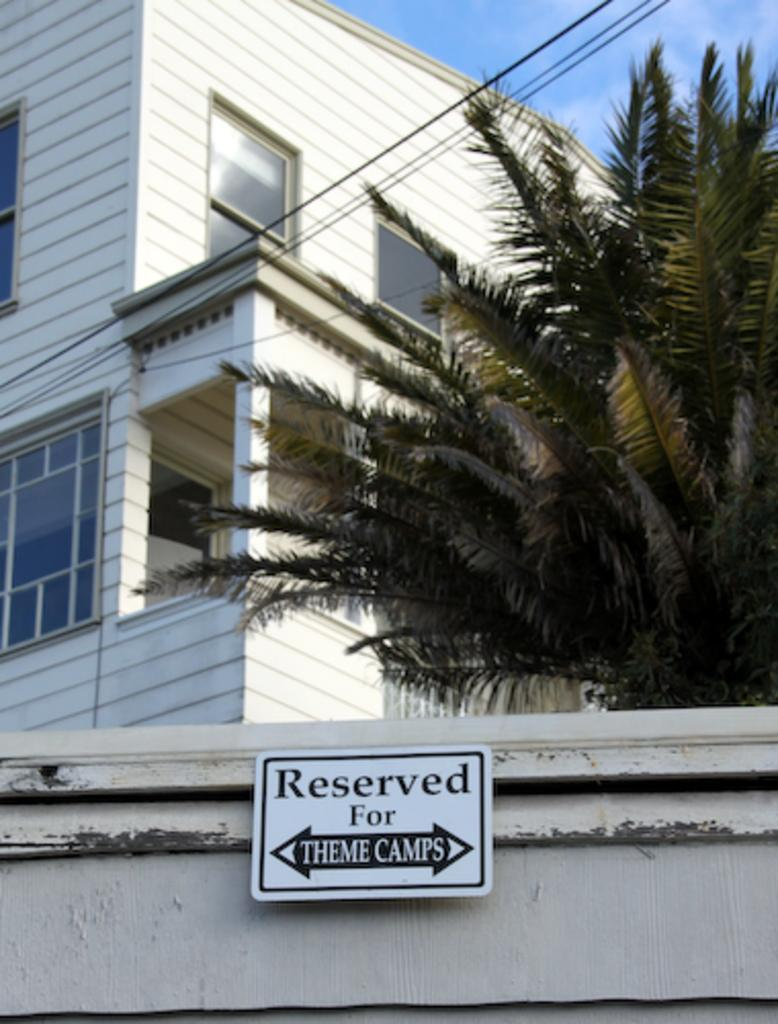What is the main object in the center of the image? There is a board in the center of the image. What can be seen in the background of the image? There is a building and a tree in the background of the image. What is visible at the top of the image? Wires and the sky are visible at the top of the image. How many sticks can be heard playing music in the image? There are no sticks playing music in the image, as it does not depict any musical instruments or sounds. 